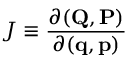Convert formula to latex. <formula><loc_0><loc_0><loc_500><loc_500>J \equiv \frac { \partial ( Q , P ) } { \partial ( q , p ) }</formula> 